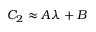Convert formula to latex. <formula><loc_0><loc_0><loc_500><loc_500>C _ { 2 } \approx A \lambda + B</formula> 